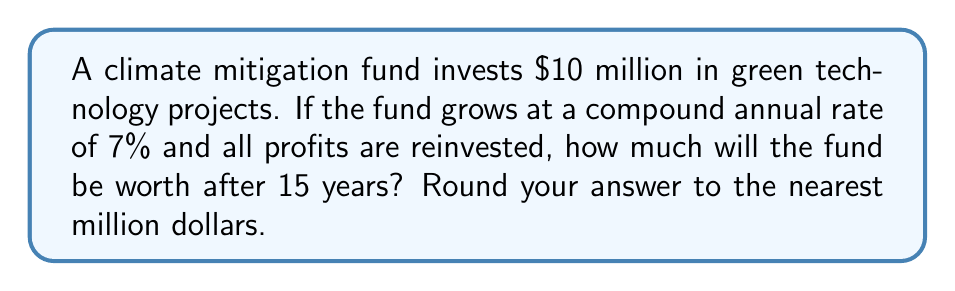Show me your answer to this math problem. To solve this problem, we'll use the compound interest formula:

$$A = P(1 + r)^t$$

Where:
$A$ = Final amount
$P$ = Principal (initial investment)
$r$ = Annual interest rate (as a decimal)
$t$ = Time in years

Given:
$P = \$10,000,000$
$r = 0.07$ (7% expressed as a decimal)
$t = 15$ years

Let's plug these values into the formula:

$$A = 10,000,000(1 + 0.07)^{15}$$

Now, let's calculate step-by-step:

1) First, calculate $(1 + 0.07)^{15}$:
   $$(1.07)^{15} \approx 2.7590$$

2) Multiply this by the principal:
   $$10,000,000 \times 2.7590 = 27,590,000$$

3) Round to the nearest million:
   $$27,590,000 \approx 28,000,000$$

Therefore, after 15 years, the climate mitigation fund will be worth approximately $28 million.
Answer: $28 million 